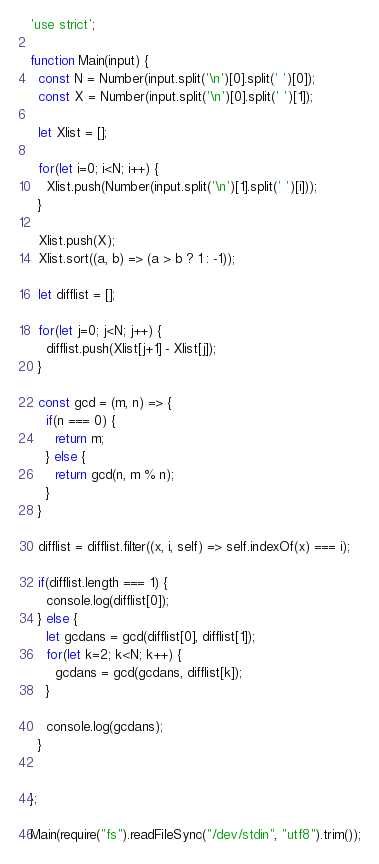<code> <loc_0><loc_0><loc_500><loc_500><_JavaScript_>'use strict';

function Main(input) {
  const N = Number(input.split('\n')[0].split(' ')[0]);
  const X = Number(input.split('\n')[0].split(' ')[1]);

  let Xlist = [];

  for(let i=0; i<N; i++) {
    Xlist.push(Number(input.split('\n')[1].split(' ')[i]));
  }

  Xlist.push(X);
  Xlist.sort((a, b) => (a > b ? 1 : -1));

  let difflist = [];

  for(let j=0; j<N; j++) {
    difflist.push(Xlist[j+1] - Xlist[j]);
  }

  const gcd = (m, n) => {
    if(n === 0) {
      return m;
    } else {
      return gcd(n, m % n);
    }
  }

  difflist = difflist.filter((x, i, self) => self.indexOf(x) === i);

  if(difflist.length === 1) {
    console.log(difflist[0]);
  } else {
    let gcdans = gcd(difflist[0], difflist[1]);
    for(let k=2; k<N; k++) {
      gcdans = gcd(gcdans, difflist[k]);
    }
  
    console.log(gcdans);
  }
  

};

Main(require("fs").readFileSync("/dev/stdin", "utf8").trim());
</code> 